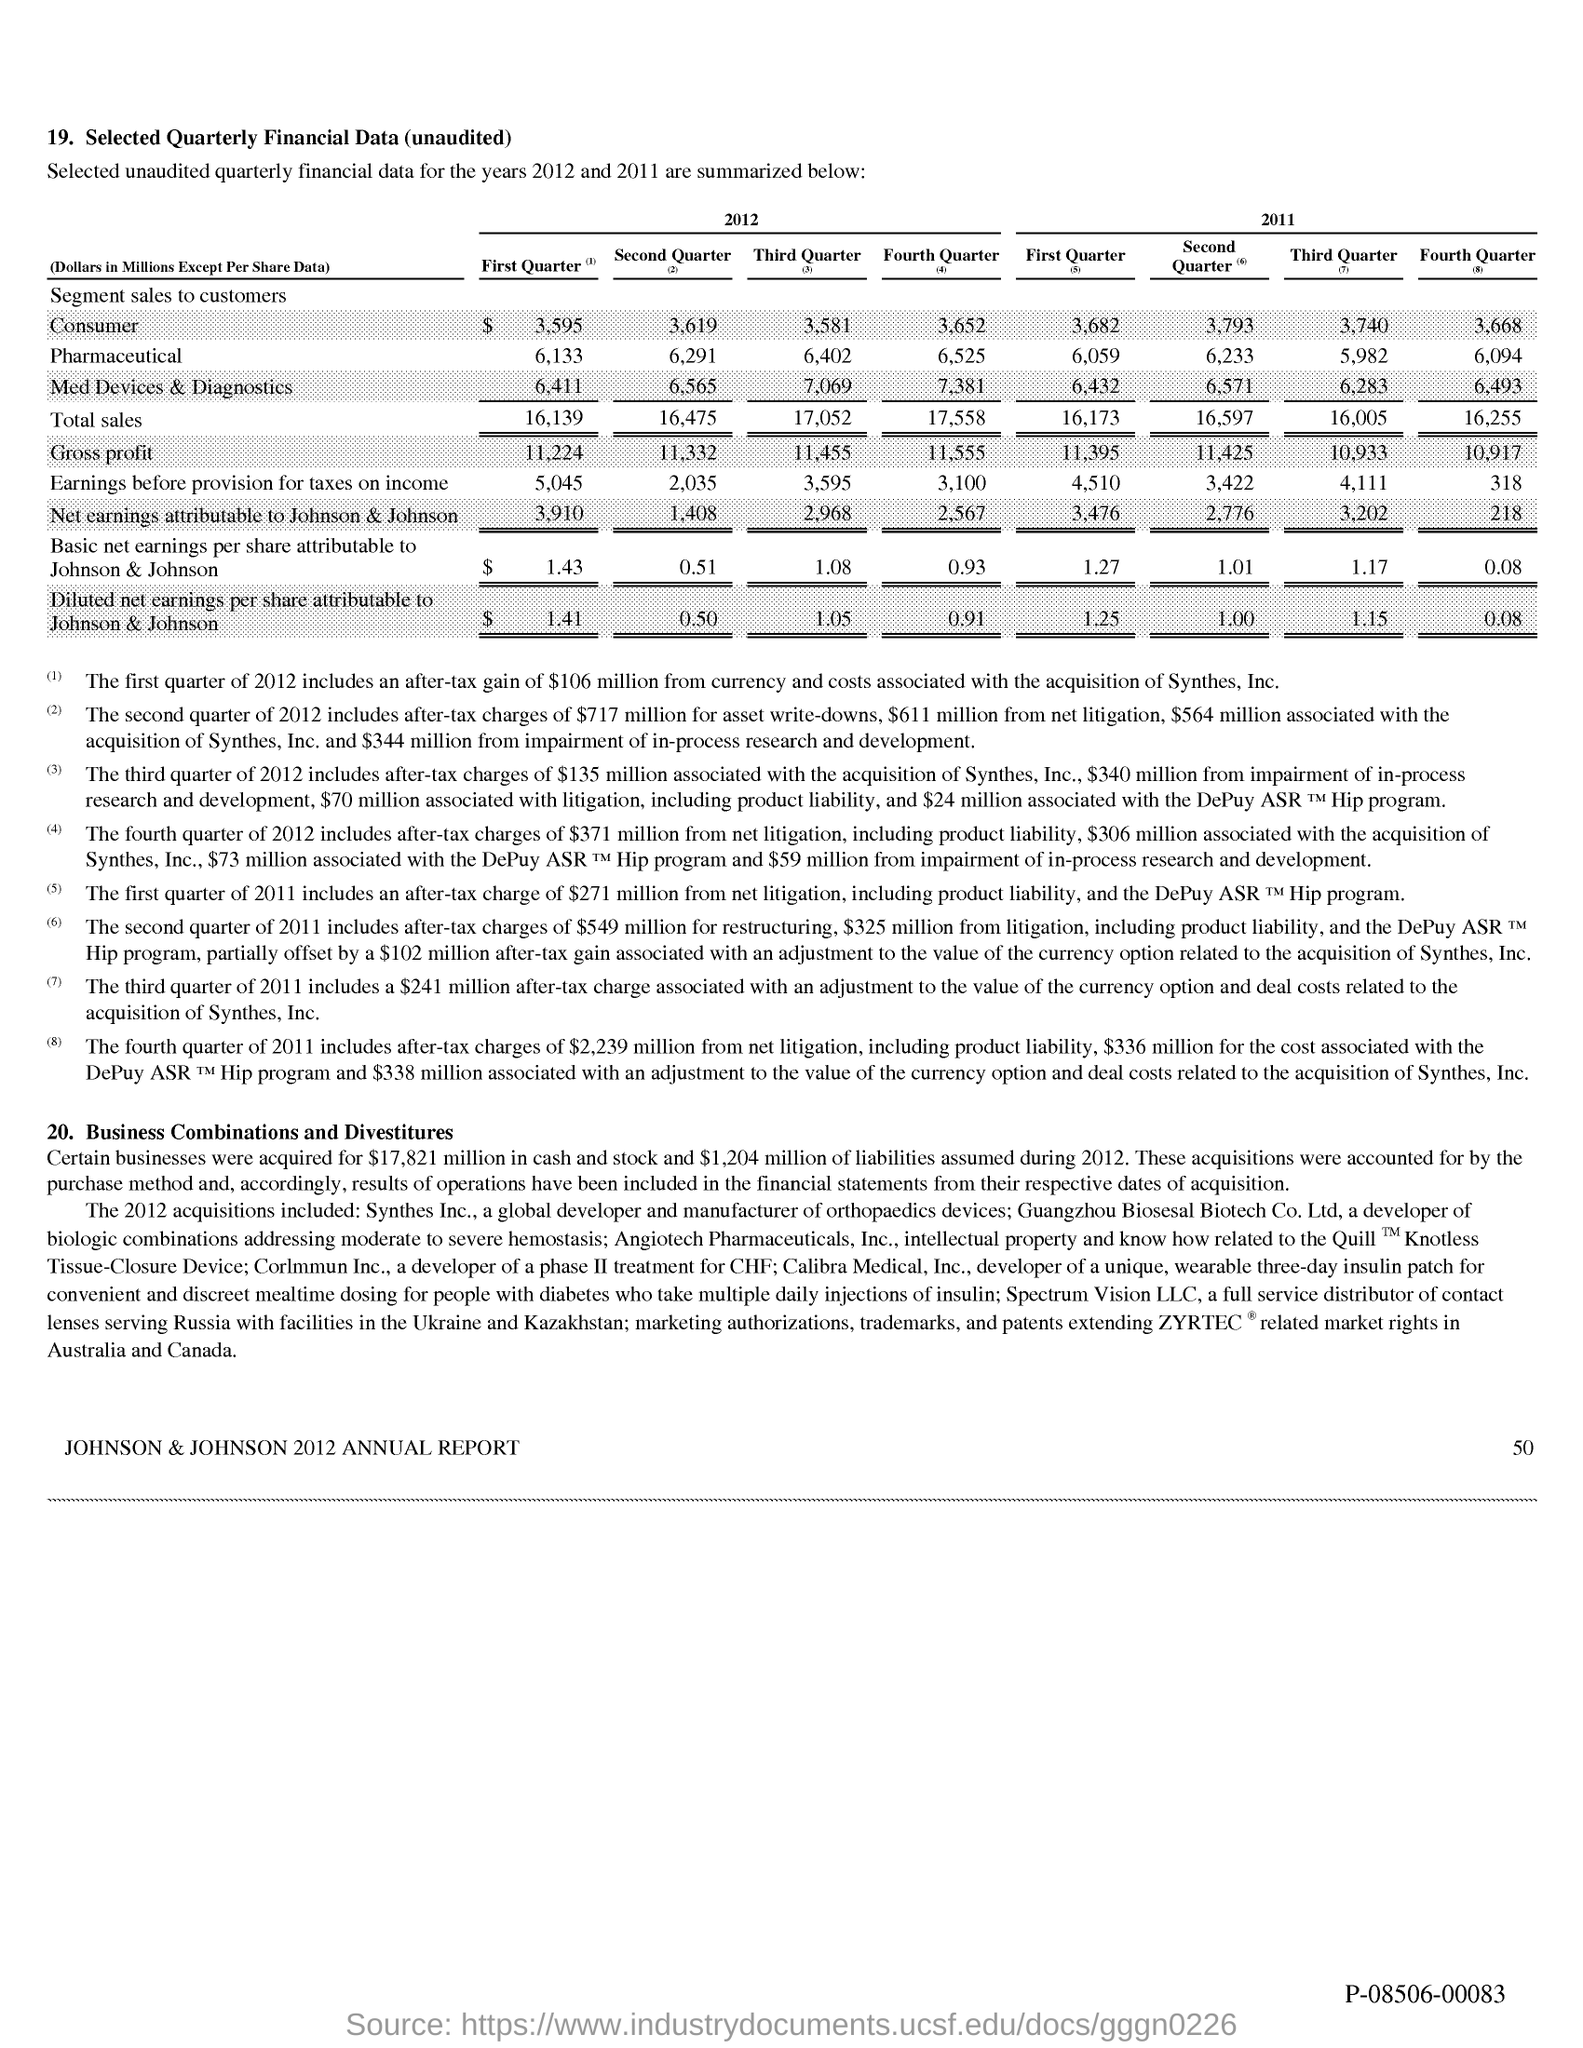What is the total sales (Dollars in Millions Except Per Share Data) in the first quarter of 2012?
Keep it short and to the point. 16,139. What is the total sales (Dollars in Millions Except Per Share Data) in the third quarter of 2012?
Offer a very short reply. 17,052. What is the net earnings attributable to Johnson & Johnson (Dollars in Millions Except Per Share Data) in the first quarter of 2011?
Provide a short and direct response. 3,476. What is the net earnings attributable to Johnson & Johnson (Dollars in Millions Except Per Share Data) in the second quarter of 2012?
Your answer should be very brief. 1,408. What is the basic net earnings per share attributable to Johnson & Johnson (Dollars in Millions Except Per Share Data) in the first quarter of 2012?
Keep it short and to the point. $  1.43. What is the total sales (Dollars in Millions Except Per Share Data) in the first quarter of 2011?
Ensure brevity in your answer.  16,173. 